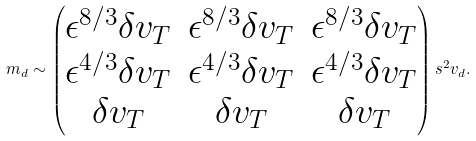Convert formula to latex. <formula><loc_0><loc_0><loc_500><loc_500>m _ { d } \sim \begin{pmatrix} \epsilon ^ { 8 / 3 } \delta v _ { T } & \epsilon ^ { 8 / 3 } \delta v _ { T } & \epsilon ^ { 8 / 3 } \delta v _ { T } \\ \epsilon ^ { 4 / 3 } \delta v _ { T } & \epsilon ^ { 4 / 3 } \delta v _ { T } & \epsilon ^ { 4 / 3 } \delta v _ { T } \\ \delta v _ { T } & \delta v _ { T } & \delta v _ { T } \end{pmatrix} s ^ { 2 } v _ { d } .</formula> 